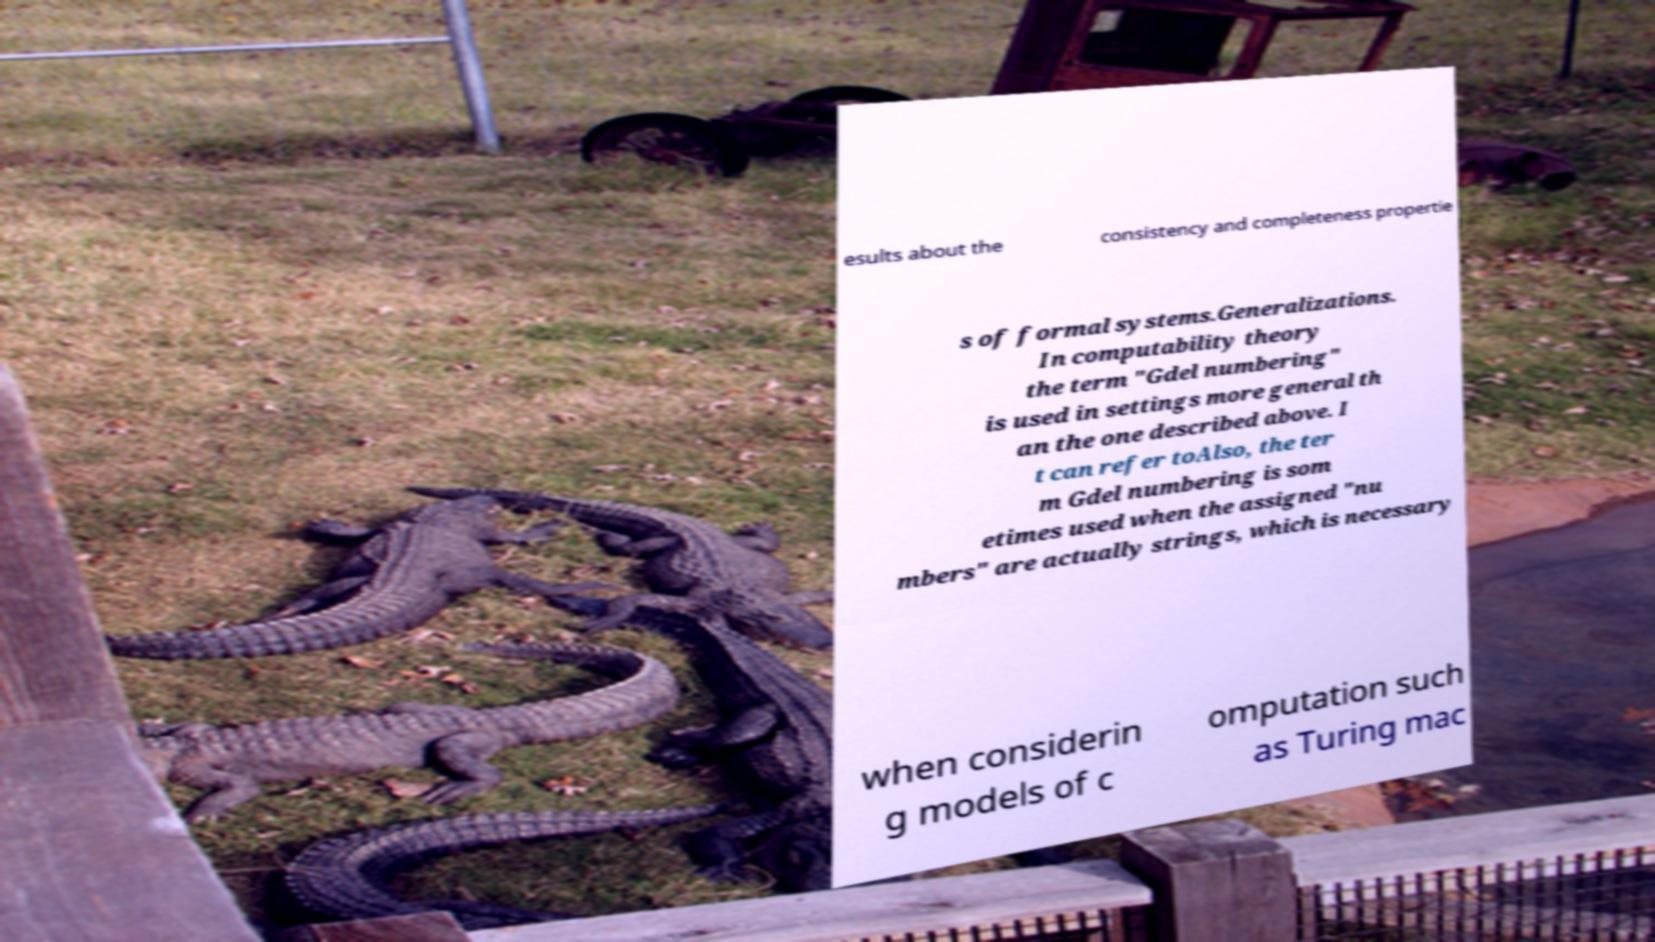Please identify and transcribe the text found in this image. esults about the consistency and completeness propertie s of formal systems.Generalizations. In computability theory the term "Gdel numbering" is used in settings more general th an the one described above. I t can refer toAlso, the ter m Gdel numbering is som etimes used when the assigned "nu mbers" are actually strings, which is necessary when considerin g models of c omputation such as Turing mac 